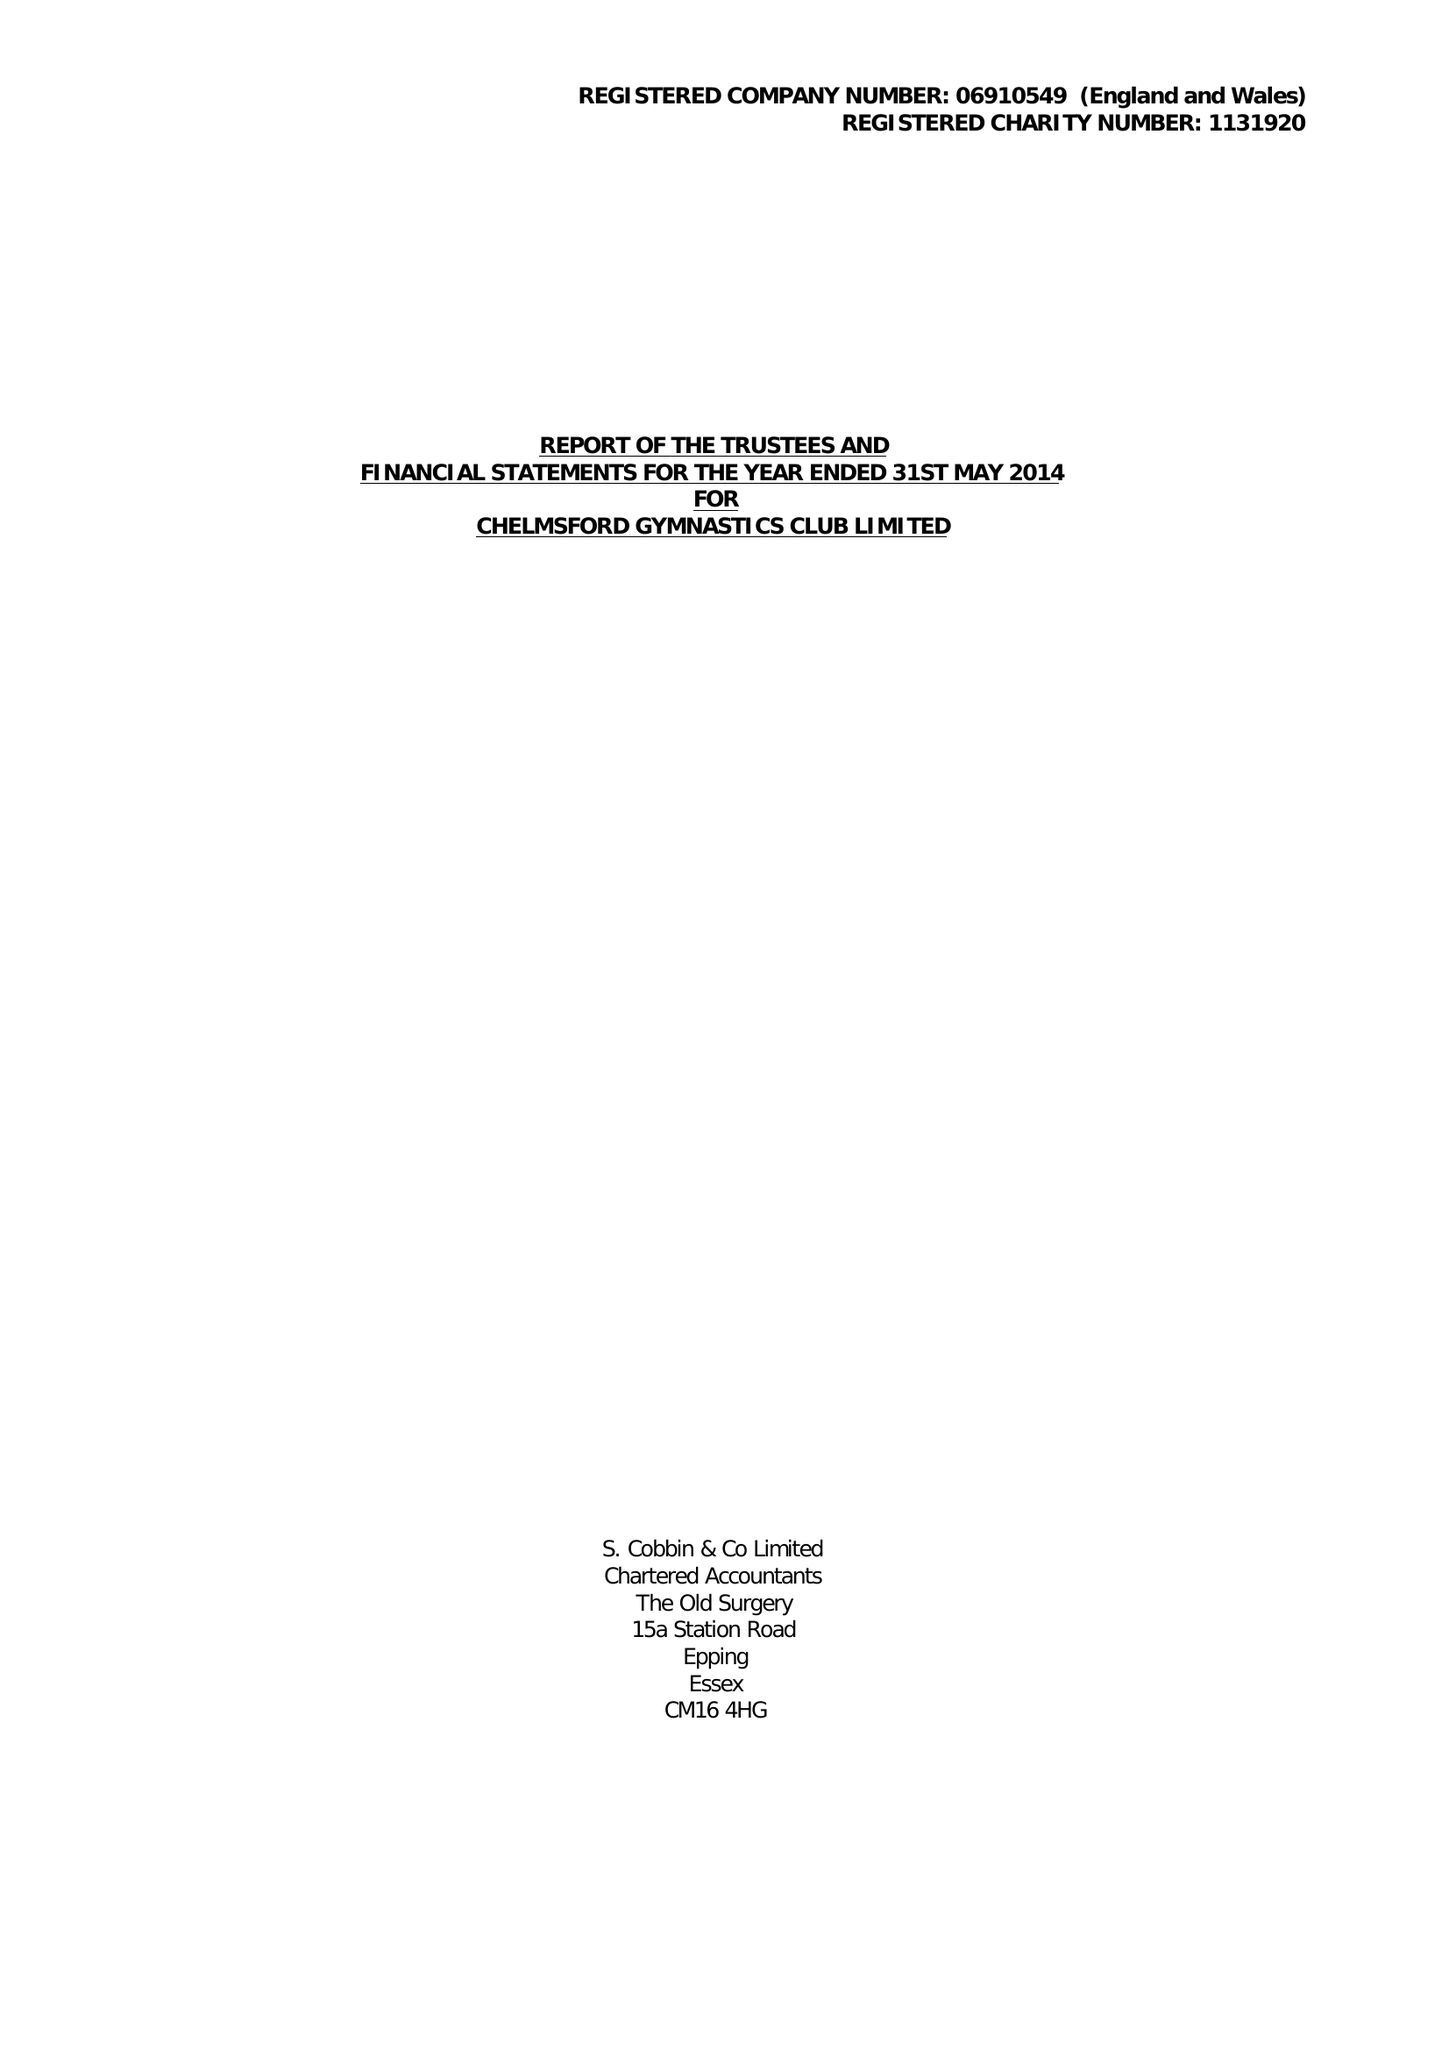What is the value for the report_date?
Answer the question using a single word or phrase. 2014-05-31 